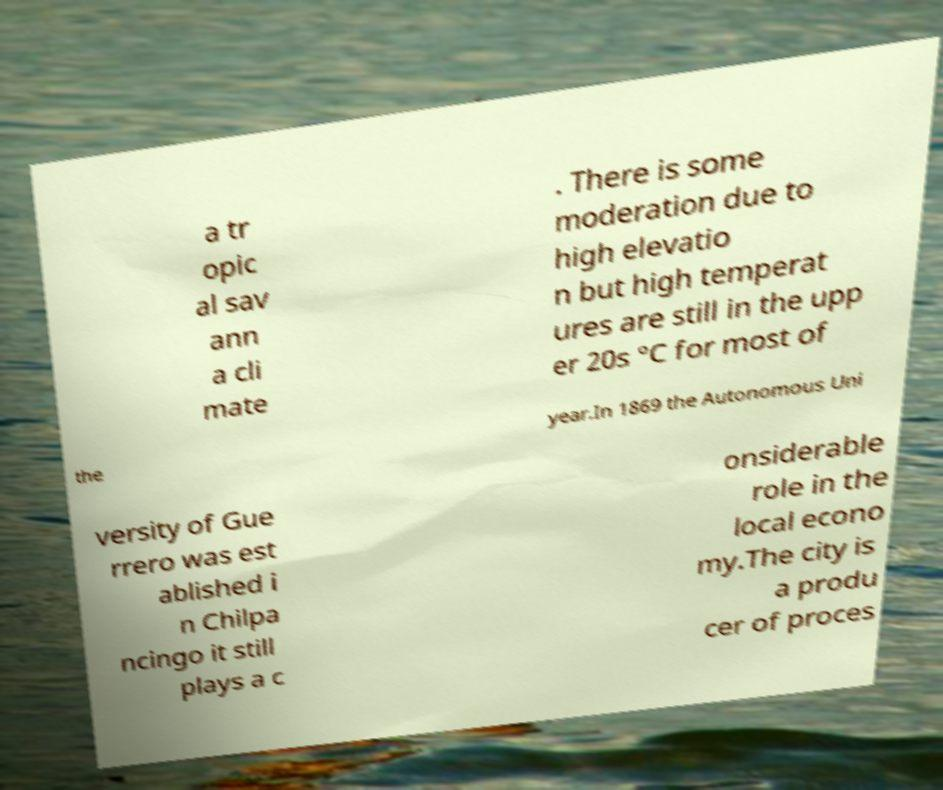What messages or text are displayed in this image? I need them in a readable, typed format. a tr opic al sav ann a cli mate . There is some moderation due to high elevatio n but high temperat ures are still in the upp er 20s °C for most of the year.In 1869 the Autonomous Uni versity of Gue rrero was est ablished i n Chilpa ncingo it still plays a c onsiderable role in the local econo my.The city is a produ cer of proces 